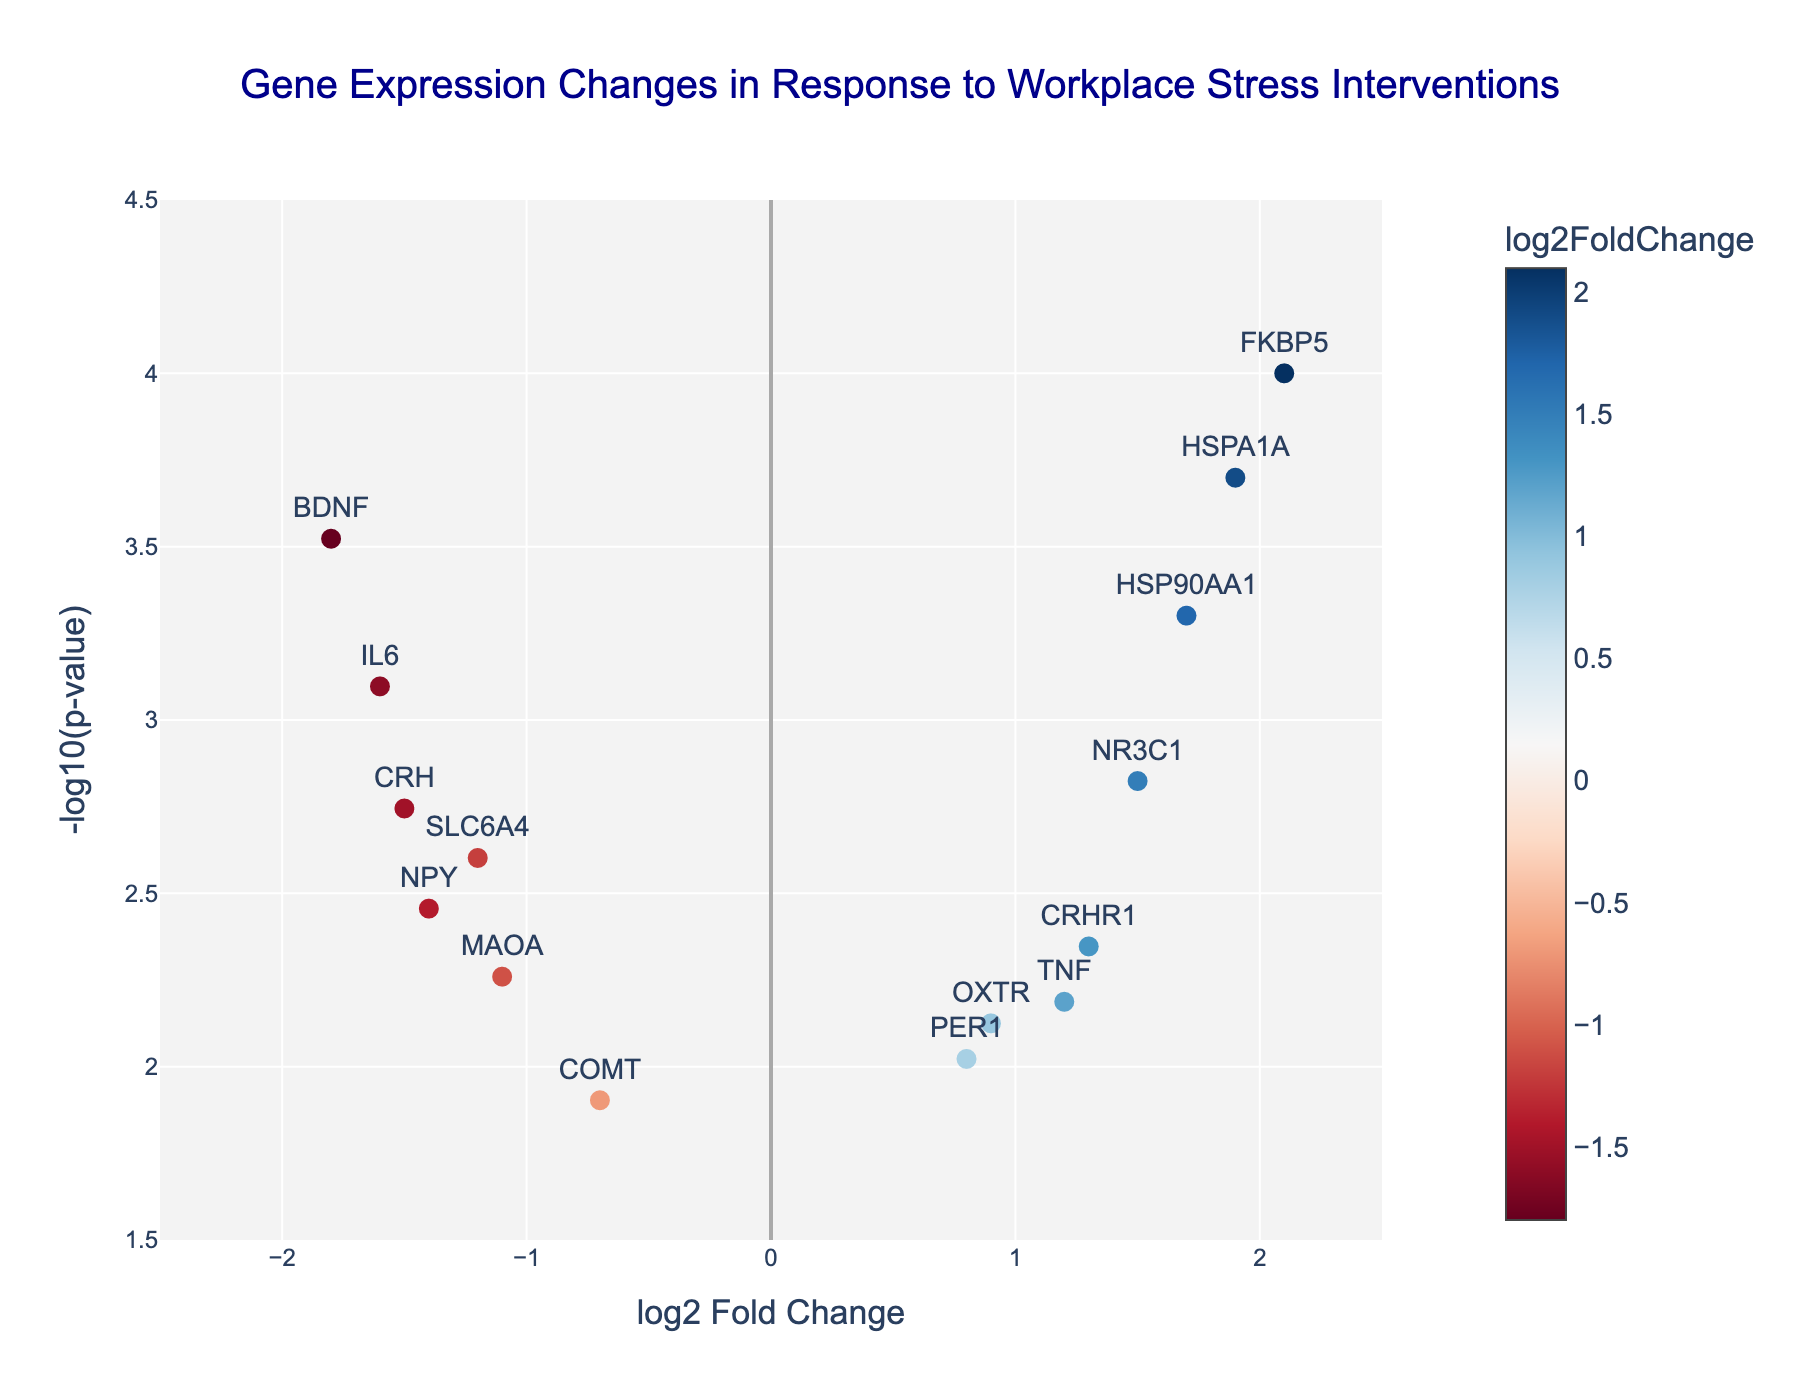How many genes show a positive log2 Fold Change? Examine the x-axis values for 'log2 Fold Change' and count the data points where these values are positive. Positive values are greater than 0. Counting these genes results in FKBP5, NR3C1, OXTR, CRHR1, TNF, HSP90AA1, and HSPA1A, making a total of 7.
Answer: 7 Which gene has the highest -log10(p-value)? The y-axis represents the '-log10(p-value)'. The gene with the highest y-axis value corresponds to the highest -log10(p-value). According to this criterion, FKBP5 has the highest value with -log10(p-value) of 4.
Answer: FKBP5 What is the log2 Fold Change for the gene with the lowest p-value? The lowest p-value corresponds to the highest -log10(p-value). FKBP5 has the lowest p-value, which means it has the highest -log10(p-value). The log2 Fold Change for FKBP5 is 2.1.
Answer: 2.1 Which gene exhibits the most substantial negative log2 Fold Change? To find the most substantial negative log2 Fold Change, look for the gene with the smallest (most negative) value on the x-axis. BDNF has the most considerable negative value at -1.8.
Answer: BDNF How many genes have a p-value less than 0.001? The p-value is converted to -log10(p-value) on the y-axis. A p-value of 0.001 corresponds to a -log10(p-value) of 3. Count the data points above 3 on the y-axis, which includes FKBP5, HSP90AA1, and HSPA1A. This gives a total of 3 genes.
Answer: 3 Which genes show both a positive log2 Fold Change and a p-value less than 0.005? For this, look for genes with positive log2 Fold Change values (x-axis > 0) and their corresponding -log10(p-value) values greater than 2.3 (since -log10(0.005) ≈ 2.3). FKBP5, NR3C1, CRHR1, HSP90AA1, and HSPA1A meet these criteria.
Answer: FKBP5, NR3C1, CRHR1, HSP90AA1, HSPA1A What is the fold change (2^log2 Fold Change) for COMT? The log2 Fold Change for COMT is -0.7. To find the fold change, calculate 2^(-0.7). This results in approximately 0.62.
Answer: 0.62 Is HSP90AA1 more affected by workplace stress interventions than NPY based on log2 Fold Change? Compare the log2 Fold Change values of HSP90AA1 and NPY. HSP90AA1 has a value of 1.7, while NPY has a value of -1.4. Since 1.7 is greater than -1.4, HSP90AA1 is more affected.
Answer: Yes Which two genes are closest together based on their log2 Fold Change and -log10(p-value)? Look at the plot for the two points that are nearest to each other. CRHR1 and TNF have similar log2 Fold Change (1.3 and 1.2) and -log10(p-value) (3.35 and 2.77). Using the Euclidean distance formula confirms their proximity is smaller than others.
Answer: CRHR1 and TNF 